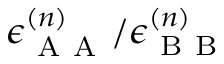Convert formula to latex. <formula><loc_0><loc_0><loc_500><loc_500>\epsilon _ { A A } ^ { ( n ) } / \epsilon _ { B B } ^ { ( n ) }</formula> 